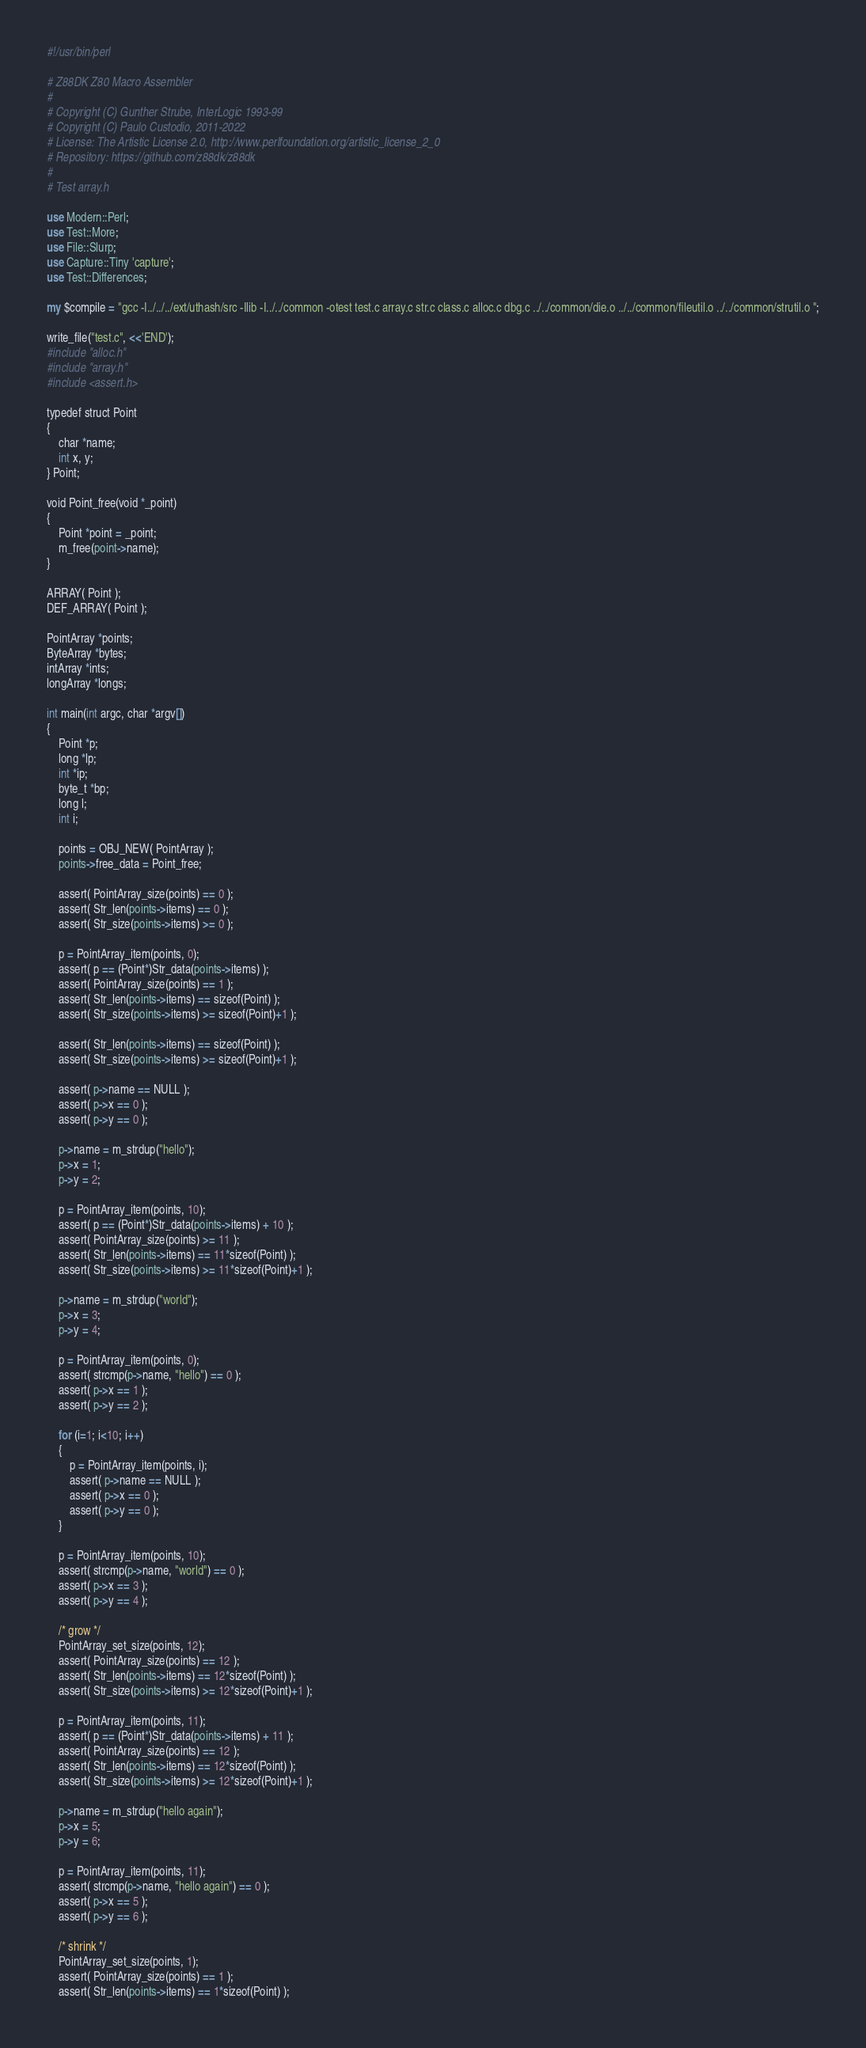<code> <loc_0><loc_0><loc_500><loc_500><_Perl_>#!/usr/bin/perl

# Z88DK Z80 Macro Assembler
#
# Copyright (C) Gunther Strube, InterLogic 1993-99
# Copyright (C) Paulo Custodio, 2011-2022
# License: The Artistic License 2.0, http://www.perlfoundation.org/artistic_license_2_0
# Repository: https://github.com/z88dk/z88dk
#
# Test array.h

use Modern::Perl;
use Test::More;
use File::Slurp;
use Capture::Tiny 'capture';
use Test::Differences; 

my $compile = "gcc -I../../../ext/uthash/src -Ilib -I../../common -otest test.c array.c str.c class.c alloc.c dbg.c ../../common/die.o ../../common/fileutil.o ../../common/strutil.o ";

write_file("test.c", <<'END');
#include "alloc.h"
#include "array.h"
#include <assert.h>

typedef struct Point 
{
	char *name;
	int x, y;
} Point;

void Point_free(void *_point) 
{
	Point *point = _point;
	m_free(point->name);
}

ARRAY( Point );
DEF_ARRAY( Point );

PointArray *points;
ByteArray *bytes;
intArray *ints;
longArray *longs;

int main(int argc, char *argv[])
{
	Point *p;
	long *lp;
	int *ip;
	byte_t *bp;
	long l;
	int i;
	
	points = OBJ_NEW( PointArray );
	points->free_data = Point_free;
	
	assert( PointArray_size(points) == 0 );
	assert( Str_len(points->items) == 0 );
	assert( Str_size(points->items) >= 0 );
	
	p = PointArray_item(points, 0);
	assert( p == (Point*)Str_data(points->items) );
	assert( PointArray_size(points) == 1 );
	assert( Str_len(points->items) == sizeof(Point) );
	assert( Str_size(points->items) >= sizeof(Point)+1 );

	assert( Str_len(points->items) == sizeof(Point) );
	assert( Str_size(points->items) >= sizeof(Point)+1 );
	
	assert( p->name == NULL );
	assert( p->x == 0 );
	assert( p->y == 0 );
	
	p->name = m_strdup("hello");
	p->x = 1;
	p->y = 2;
	
	p = PointArray_item(points, 10);
	assert( p == (Point*)Str_data(points->items) + 10 );
	assert( PointArray_size(points) >= 11 );
	assert( Str_len(points->items) == 11*sizeof(Point) );
	assert( Str_size(points->items) >= 11*sizeof(Point)+1 );

	p->name = m_strdup("world");
	p->x = 3;
	p->y = 4;
	
	p = PointArray_item(points, 0);
	assert( strcmp(p->name, "hello") == 0 );
	assert( p->x == 1 );
	assert( p->y == 2 );
	
	for (i=1; i<10; i++) 
	{
		p = PointArray_item(points, i);
		assert( p->name == NULL );
		assert( p->x == 0 );
		assert( p->y == 0 );
	}

	p = PointArray_item(points, 10);
	assert( strcmp(p->name, "world") == 0 );
	assert( p->x == 3 );
	assert( p->y == 4 );
	
	/* grow */
	PointArray_set_size(points, 12);
	assert( PointArray_size(points) == 12 );
	assert( Str_len(points->items) == 12*sizeof(Point) );
	assert( Str_size(points->items) >= 12*sizeof(Point)+1 );

	p = PointArray_item(points, 11);
	assert( p == (Point*)Str_data(points->items) + 11 );
	assert( PointArray_size(points) == 12 );
	assert( Str_len(points->items) == 12*sizeof(Point) );
	assert( Str_size(points->items) >= 12*sizeof(Point)+1 );

	p->name = m_strdup("hello again");
	p->x = 5;
	p->y = 6;
	
	p = PointArray_item(points, 11);
	assert( strcmp(p->name, "hello again") == 0 );
	assert( p->x == 5 );
	assert( p->y == 6 );
	
	/* shrink */
	PointArray_set_size(points, 1);
	assert( PointArray_size(points) == 1 );
	assert( Str_len(points->items) == 1*sizeof(Point) );</code> 